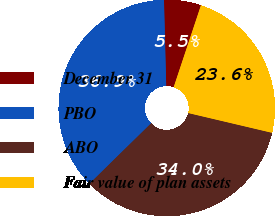Convert chart. <chart><loc_0><loc_0><loc_500><loc_500><pie_chart><fcel>December 31<fcel>PBO<fcel>ABO<fcel>Fair value of plan assets<nl><fcel>5.53%<fcel>36.93%<fcel>33.97%<fcel>23.57%<nl></chart> 